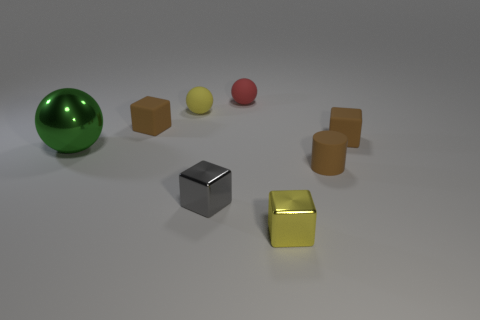Add 2 yellow metallic things. How many objects exist? 10 Subtract all yellow balls. How many balls are left? 2 Subtract all tiny yellow shiny cubes. How many cubes are left? 3 Subtract 1 brown cylinders. How many objects are left? 7 Subtract all balls. How many objects are left? 5 Subtract all yellow spheres. Subtract all brown cylinders. How many spheres are left? 2 Subtract all brown cylinders. How many red balls are left? 1 Subtract all brown matte blocks. Subtract all rubber balls. How many objects are left? 4 Add 2 shiny spheres. How many shiny spheres are left? 3 Add 1 brown things. How many brown things exist? 4 